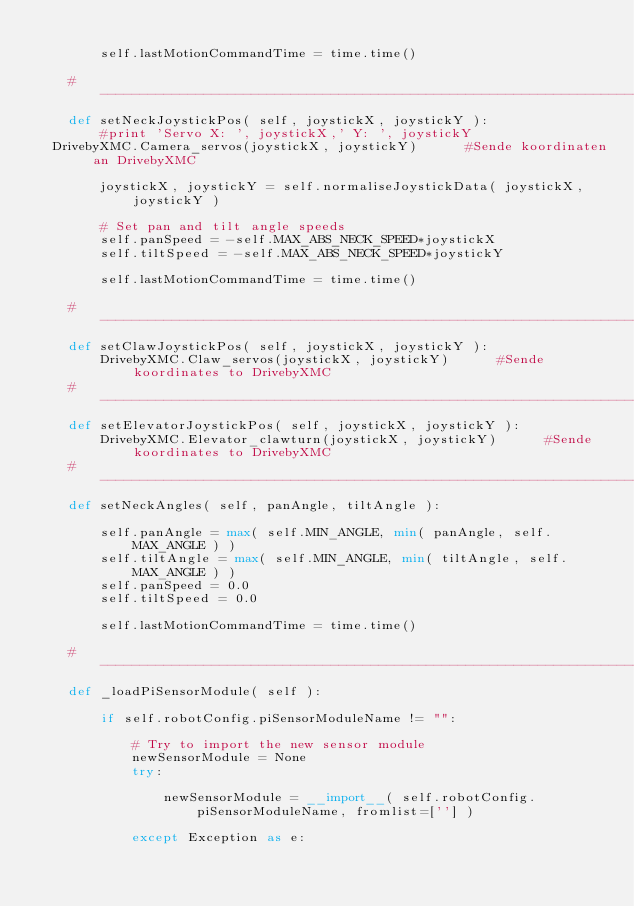Convert code to text. <code><loc_0><loc_0><loc_500><loc_500><_Python_>        
        self.lastMotionCommandTime = time.time()
    
    #-----------------------------------------------------------------------------------------------
    def setNeckJoystickPos( self, joystickX, joystickY ):
        #print 'Servo X: ', joystickX,' Y: ', joystickY
	DrivebyXMC.Camera_servos(joystickX, joystickY)			#Sende koordinaten an DrivebyXMC
        
        joystickX, joystickY = self.normaliseJoystickData( joystickX, joystickY )
        
        # Set pan and tilt angle speeds
        self.panSpeed = -self.MAX_ABS_NECK_SPEED*joystickX
        self.tiltSpeed = -self.MAX_ABS_NECK_SPEED*joystickY
        
        self.lastMotionCommandTime = time.time()
    
    #-----------------------------------------------------------------------------------------------
    def setClawJoystickPos( self, joystickX, joystickY ):
        DrivebyXMC.Claw_servos(joystickX, joystickY)			#Sende koordinates to DrivebyXMC
    #-----------------------------------------------------------------------------------------------
    def setElevatorJoystickPos( self, joystickX, joystickY ):
        DrivebyXMC.Elevator_clawturn(joystickX, joystickY)			#Sende koordinates to DrivebyXMC
    #-----------------------------------------------------------------------------------------------
    def setNeckAngles( self, panAngle, tiltAngle ):
        
        self.panAngle = max( self.MIN_ANGLE, min( panAngle, self.MAX_ANGLE ) )
        self.tiltAngle = max( self.MIN_ANGLE, min( tiltAngle, self.MAX_ANGLE ) )
        self.panSpeed = 0.0
        self.tiltSpeed = 0.0
        
        self.lastMotionCommandTime = time.time()
    
    #-----------------------------------------------------------------------------------------------
    def _loadPiSensorModule( self ):
        
        if self.robotConfig.piSensorModuleName != "":
            
            # Try to import the new sensor module
            newSensorModule = None
            try:
                
                newSensorModule = __import__( self.robotConfig.piSensorModuleName, fromlist=[''] )
                
            except Exception as e:</code> 